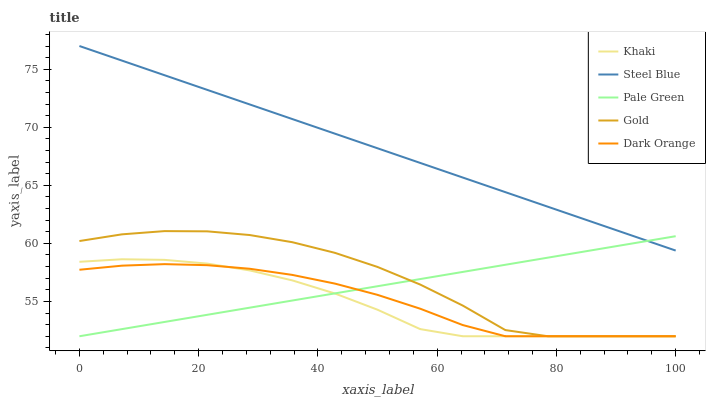Does Steel Blue have the minimum area under the curve?
Answer yes or no. No. Does Khaki have the maximum area under the curve?
Answer yes or no. No. Is Khaki the smoothest?
Answer yes or no. No. Is Khaki the roughest?
Answer yes or no. No. Does Steel Blue have the lowest value?
Answer yes or no. No. Does Khaki have the highest value?
Answer yes or no. No. Is Gold less than Steel Blue?
Answer yes or no. Yes. Is Steel Blue greater than Dark Orange?
Answer yes or no. Yes. Does Gold intersect Steel Blue?
Answer yes or no. No. 